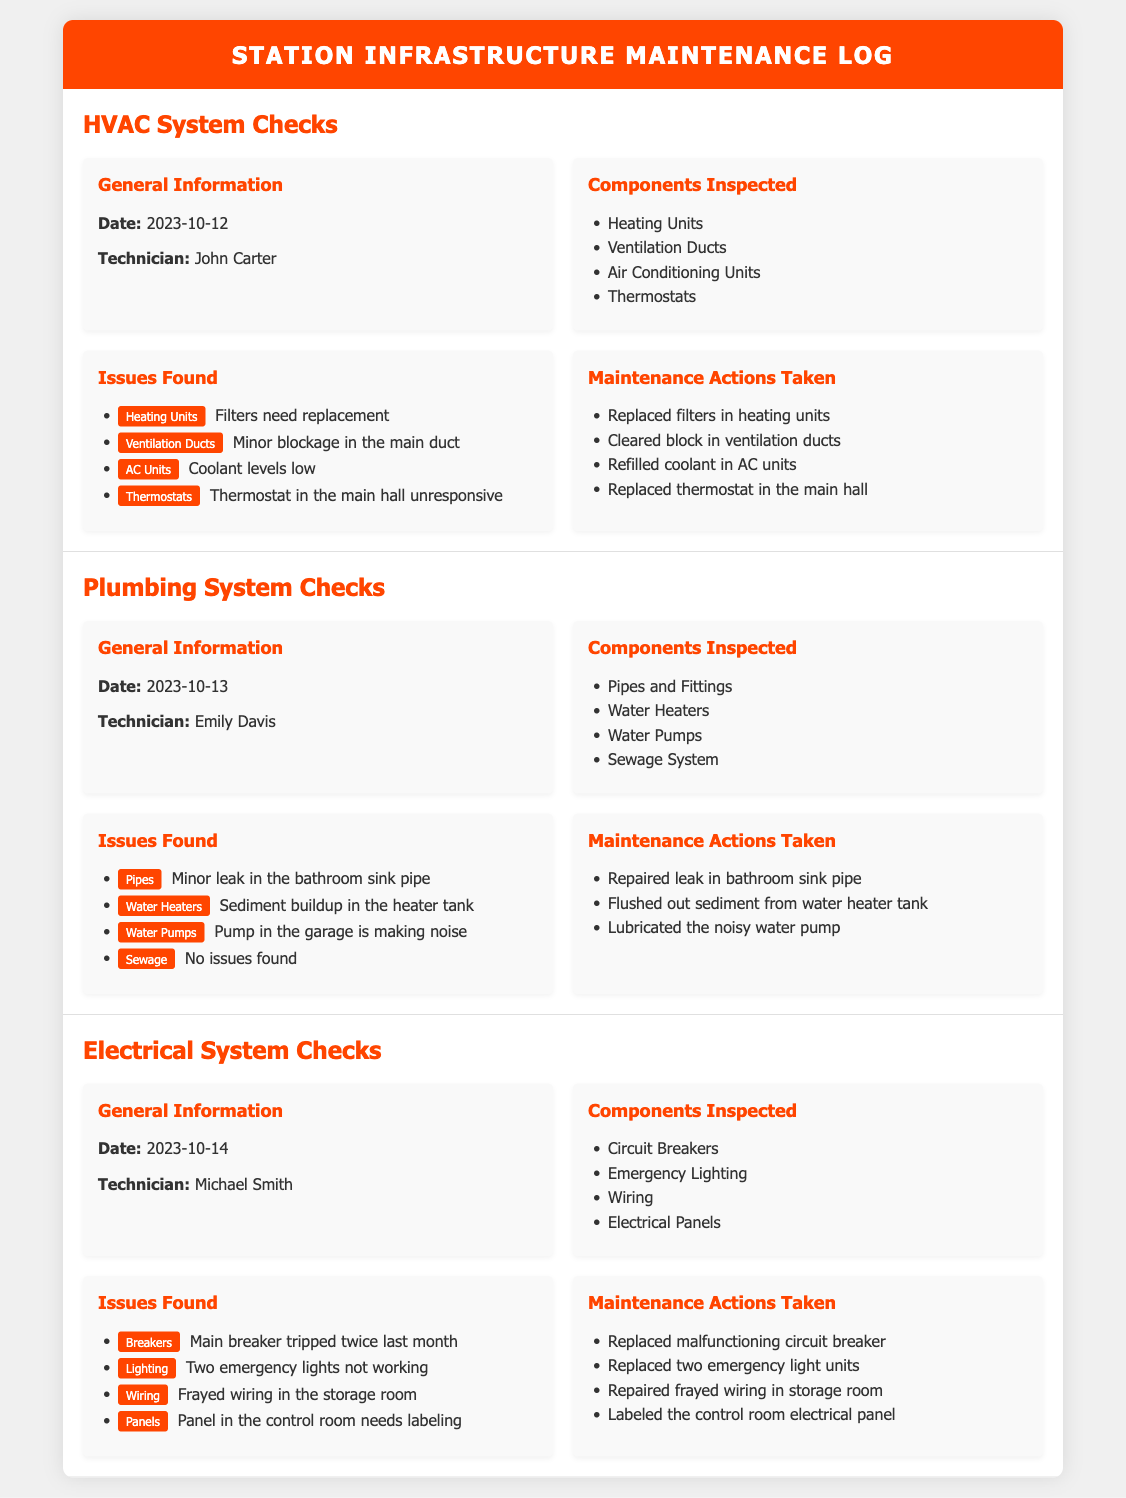What is the date of the HVAC system checks? The date of the HVAC system checks is specified in the log as 2023-10-12.
Answer: 2023-10-12 Who performed the plumbing system checks? The plumbing system checks were conducted by Emily Davis, as indicated in the log.
Answer: Emily Davis What was one issue found in the HVAC system? One issue found was that the filters in the heating units need replacement, which is detailed in the document.
Answer: Filters need replacement How many emergency lights were found to be non-functional? The document states that two emergency lights were not working during the electrical system checks.
Answer: Two What maintenance action was taken for the AC units? The maintenance action taken for the AC units was refilling the coolant, as noted in the HVAC section.
Answer: Refilled coolant in AC units What component was inspected along with pipes and fittings in the plumbing system? Water heaters were inspected along with pipes and fittings, according to the components inspected section.
Answer: Water Heaters How many HVAC components were inspected in total? A total of four components were inspected in the HVAC system checks: heating units, ventilation ducts, air conditioning units, and thermostats.
Answer: Four What issue was identified with the water pumps? The document notes that the water pump in the garage is making noise, which is the issue identified.
Answer: Pump in the garage is making noise What was done to address the frayed wiring during the electrical check? The action taken was repairing the frayed wiring in the storage room, as detailed in the electrical maintenance actions.
Answer: Repaired frayed wiring 